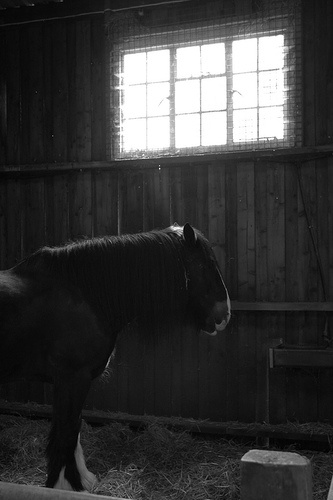Describe the objects in this image and their specific colors. I can see a horse in black, gray, darkgray, and lightgray tones in this image. 